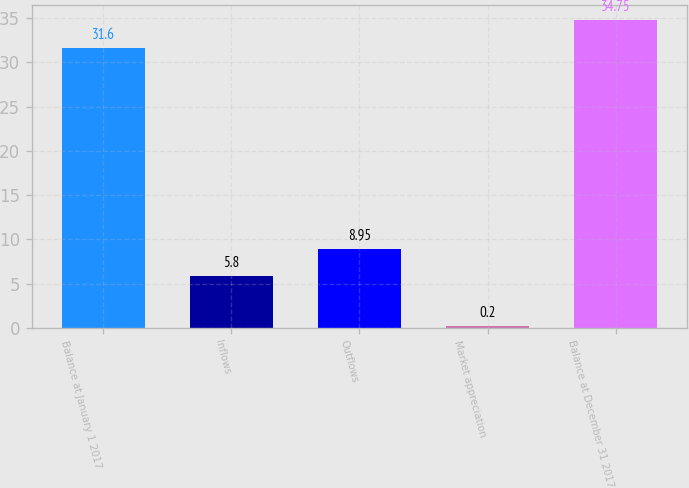<chart> <loc_0><loc_0><loc_500><loc_500><bar_chart><fcel>Balance at January 1 2017<fcel>Inflows<fcel>Outflows<fcel>Market appreciation<fcel>Balance at December 31 2017<nl><fcel>31.6<fcel>5.8<fcel>8.95<fcel>0.2<fcel>34.75<nl></chart> 